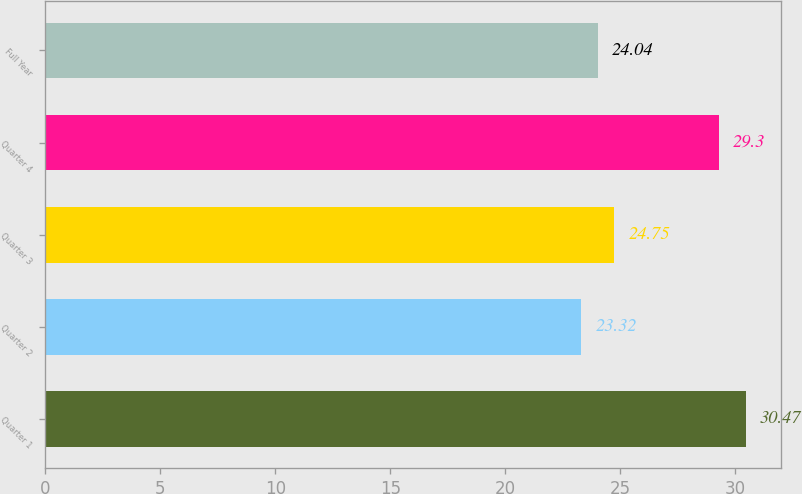Convert chart to OTSL. <chart><loc_0><loc_0><loc_500><loc_500><bar_chart><fcel>Quarter 1<fcel>Quarter 2<fcel>Quarter 3<fcel>Quarter 4<fcel>Full Year<nl><fcel>30.47<fcel>23.32<fcel>24.75<fcel>29.3<fcel>24.04<nl></chart> 